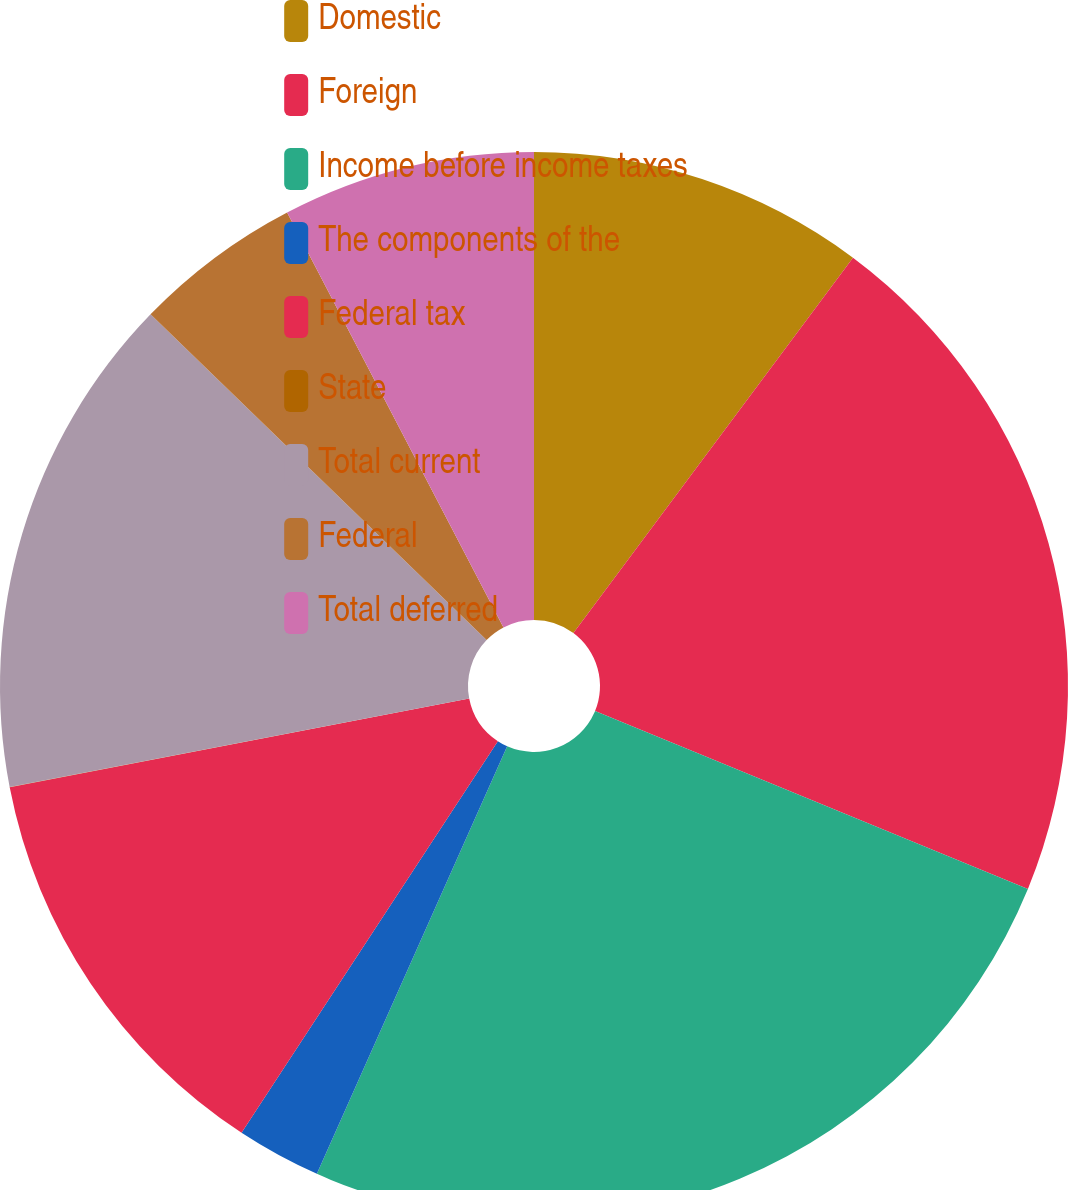Convert chart. <chart><loc_0><loc_0><loc_500><loc_500><pie_chart><fcel>Domestic<fcel>Foreign<fcel>Income before income taxes<fcel>The components of the<fcel>Federal tax<fcel>State<fcel>Total current<fcel>Federal<fcel>Total deferred<nl><fcel>10.19%<fcel>21.02%<fcel>25.46%<fcel>2.56%<fcel>12.74%<fcel>0.01%<fcel>15.28%<fcel>5.1%<fcel>7.65%<nl></chart> 